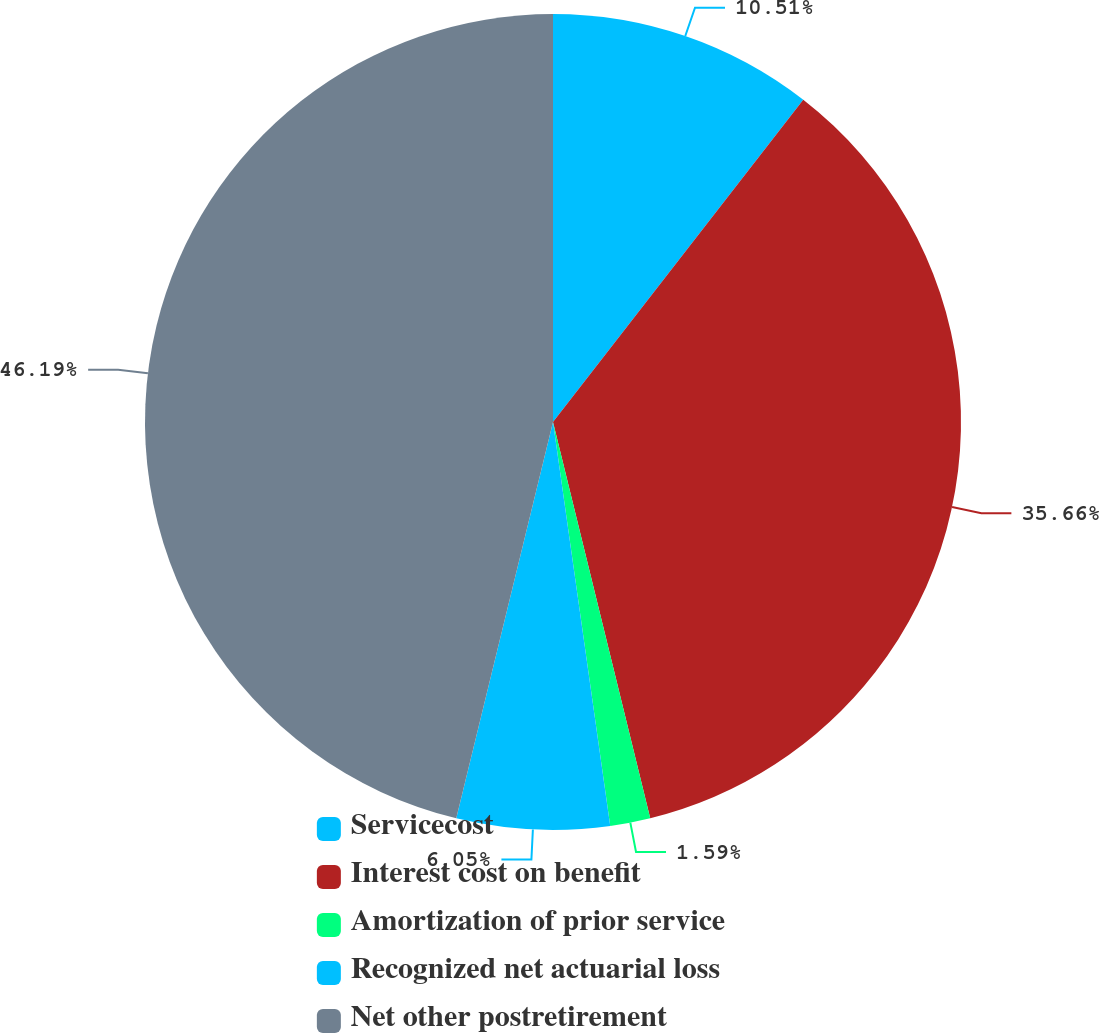<chart> <loc_0><loc_0><loc_500><loc_500><pie_chart><fcel>Servicecost<fcel>Interest cost on benefit<fcel>Amortization of prior service<fcel>Recognized net actuarial loss<fcel>Net other postretirement<nl><fcel>10.51%<fcel>35.66%<fcel>1.59%<fcel>6.05%<fcel>46.19%<nl></chart> 